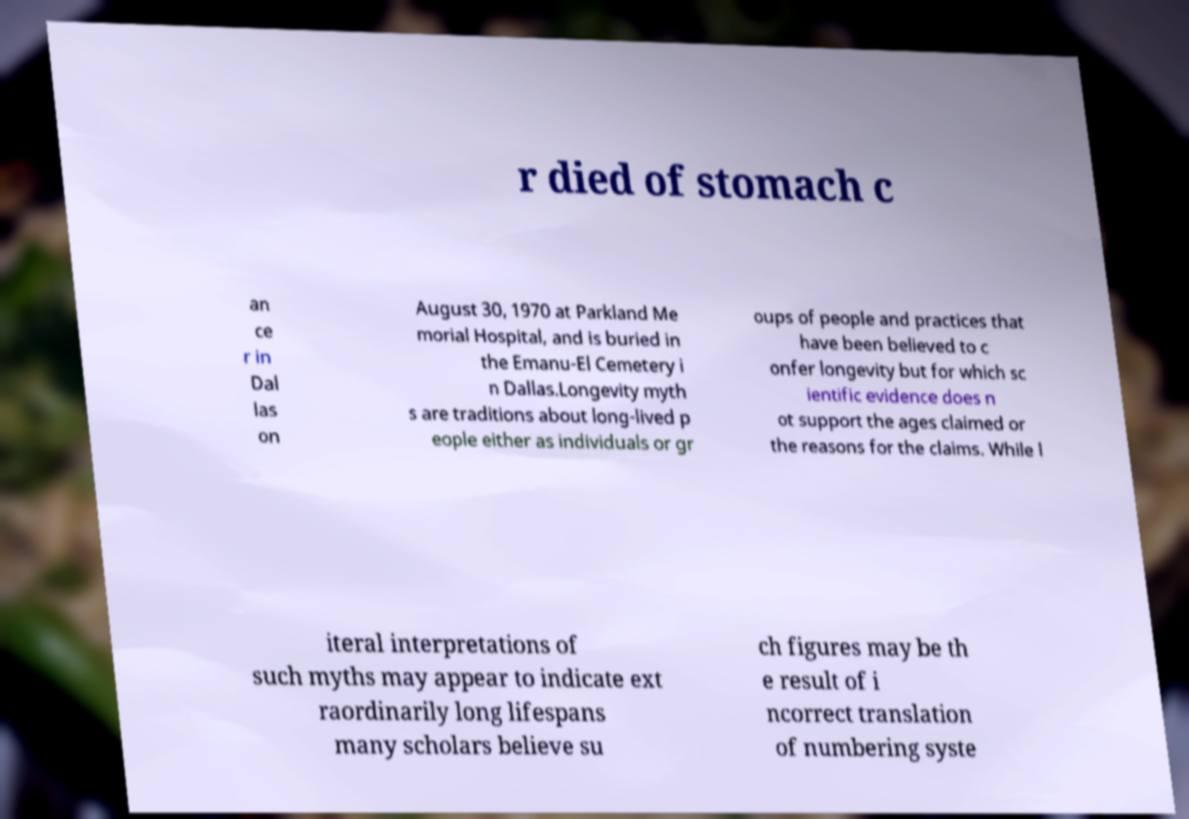What messages or text are displayed in this image? I need them in a readable, typed format. r died of stomach c an ce r in Dal las on August 30, 1970 at Parkland Me morial Hospital, and is buried in the Emanu-El Cemetery i n Dallas.Longevity myth s are traditions about long-lived p eople either as individuals or gr oups of people and practices that have been believed to c onfer longevity but for which sc ientific evidence does n ot support the ages claimed or the reasons for the claims. While l iteral interpretations of such myths may appear to indicate ext raordinarily long lifespans many scholars believe su ch figures may be th e result of i ncorrect translation of numbering syste 